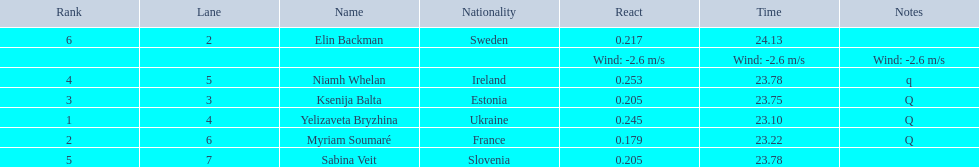Which player is from ireland? Niamh Whelan. 